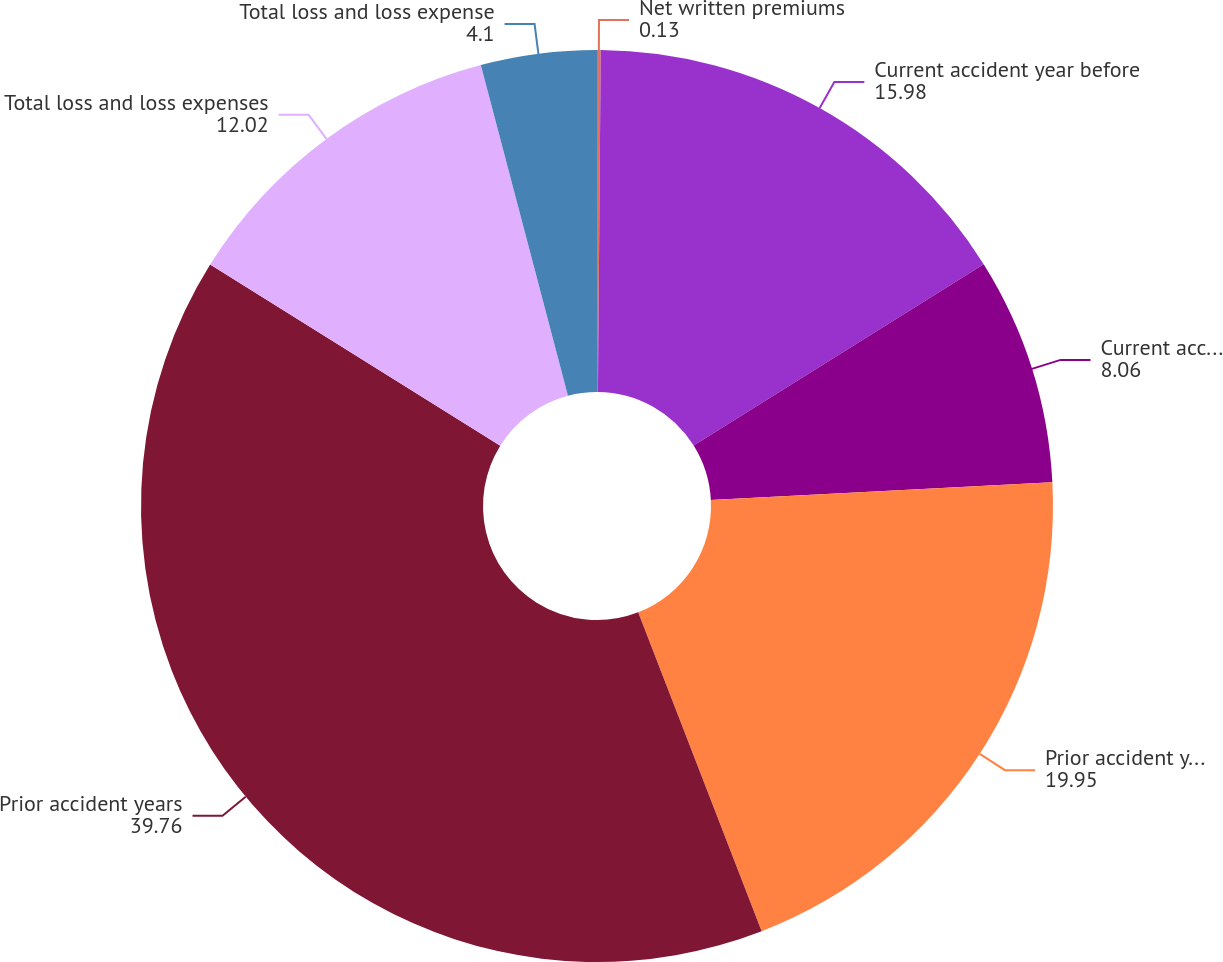<chart> <loc_0><loc_0><loc_500><loc_500><pie_chart><fcel>Net written premiums<fcel>Current accident year before<fcel>Current accident year<fcel>Prior accident years before<fcel>Prior accident years<fcel>Total loss and loss expenses<fcel>Total loss and loss expense<nl><fcel>0.13%<fcel>15.98%<fcel>8.06%<fcel>19.95%<fcel>39.76%<fcel>12.02%<fcel>4.1%<nl></chart> 